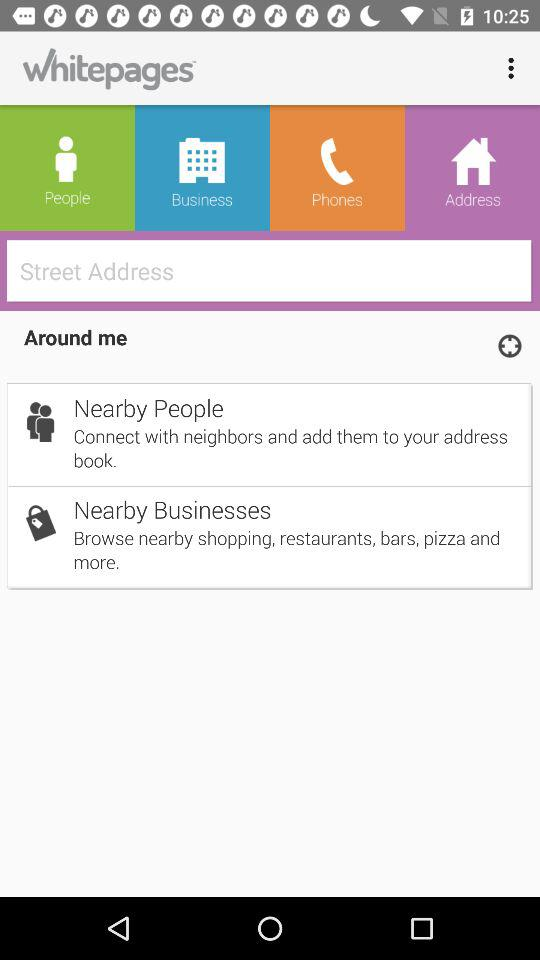What is the name of the application? The name of the application is "Whitepages". 